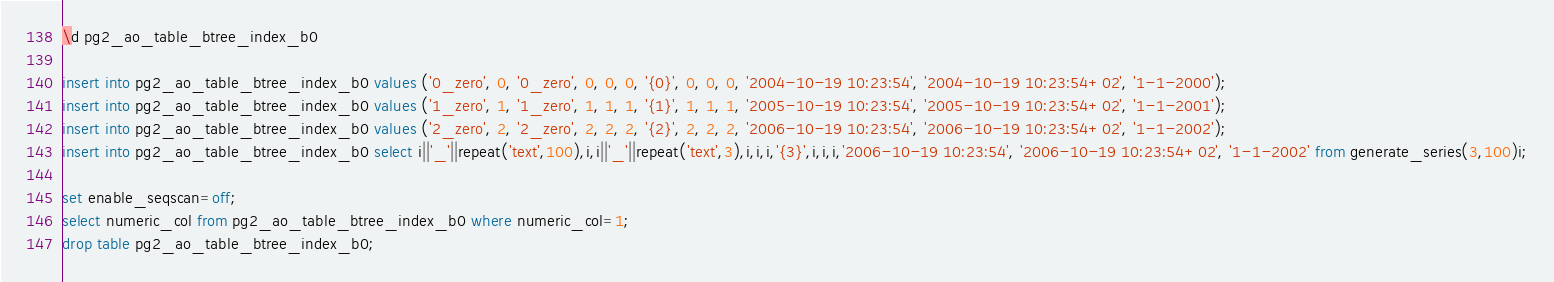<code> <loc_0><loc_0><loc_500><loc_500><_SQL_>\d pg2_ao_table_btree_index_b0

insert into pg2_ao_table_btree_index_b0 values ('0_zero', 0, '0_zero', 0, 0, 0, '{0}', 0, 0, 0, '2004-10-19 10:23:54', '2004-10-19 10:23:54+02', '1-1-2000');
insert into pg2_ao_table_btree_index_b0 values ('1_zero', 1, '1_zero', 1, 1, 1, '{1}', 1, 1, 1, '2005-10-19 10:23:54', '2005-10-19 10:23:54+02', '1-1-2001');
insert into pg2_ao_table_btree_index_b0 values ('2_zero', 2, '2_zero', 2, 2, 2, '{2}', 2, 2, 2, '2006-10-19 10:23:54', '2006-10-19 10:23:54+02', '1-1-2002');
insert into pg2_ao_table_btree_index_b0 select i||'_'||repeat('text',100),i,i||'_'||repeat('text',3),i,i,i,'{3}',i,i,i,'2006-10-19 10:23:54', '2006-10-19 10:23:54+02', '1-1-2002' from generate_series(3,100)i;

set enable_seqscan=off;
select numeric_col from pg2_ao_table_btree_index_b0 where numeric_col=1;
drop table pg2_ao_table_btree_index_b0;
</code> 